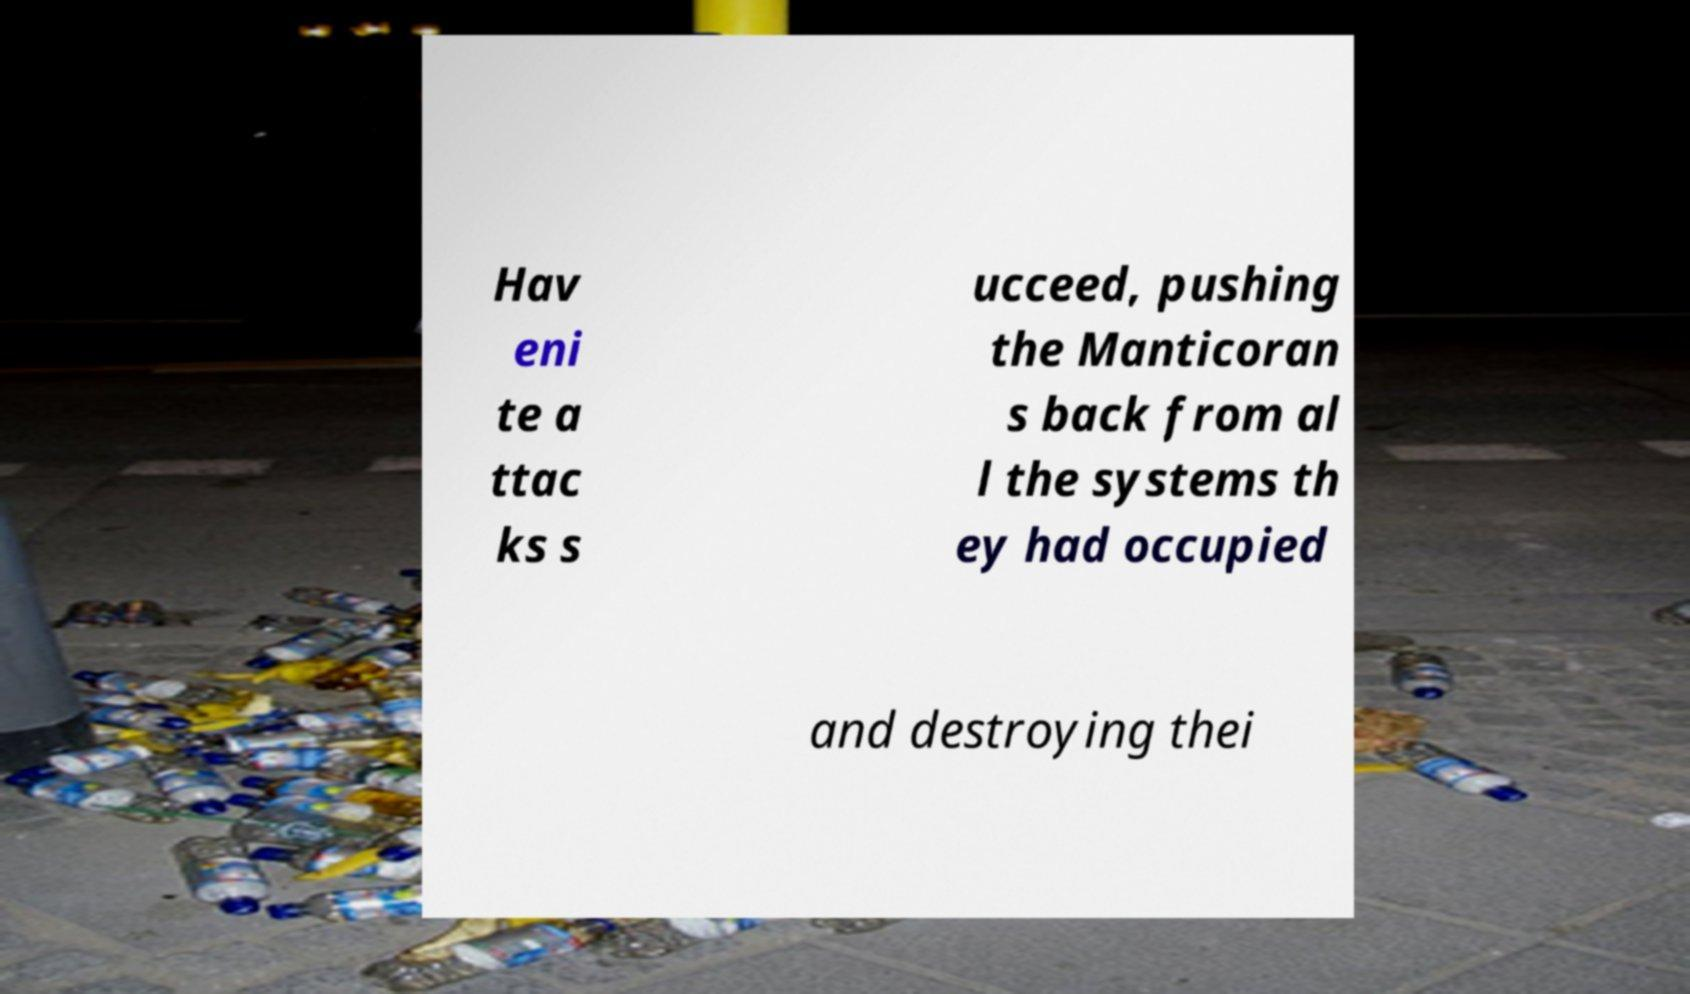Please read and relay the text visible in this image. What does it say? Hav eni te a ttac ks s ucceed, pushing the Manticoran s back from al l the systems th ey had occupied and destroying thei 